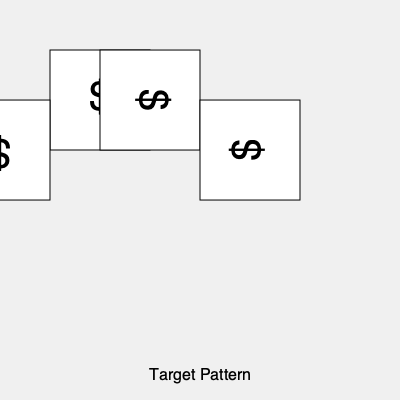A client's invoicing system uses rotating dollar sign icons to represent different expense categories. To optimize the system, you need to determine the minimum number of 90-degree rotations required to align all icons with the target pattern shown above. Each icon can be rotated clockwise in 90-degree increments. How many total rotations are needed? To solve this problem, we need to analyze each icon's current position and determine how many 90-degree rotations are needed to match the target pattern. Let's go through each icon:

1. Top-left icon: Already in the correct position. Rotations needed = 0

2. Top-right icon: Currently rotated 90° clockwise. To match the target, it needs 3 more 90° rotations clockwise (or 1 counterclockwise, but we're using clockwise rotations). Rotations needed = 3

3. Bottom-left icon: Currently rotated 180°. To match the target, it needs 2 more 90° rotations clockwise. Rotations needed = 2

4. Bottom-right icon: Currently rotated 270° clockwise (or 90° counterclockwise). To match the target, it needs 1 more 90° rotation clockwise. Rotations needed = 1

To get the total number of rotations, we sum up the rotations needed for each icon:

Total rotations = 0 + 3 + 2 + 1 = 6

Therefore, the minimum number of 90-degree clockwise rotations required to align all icons with the target pattern is 6.
Answer: 6 rotations 